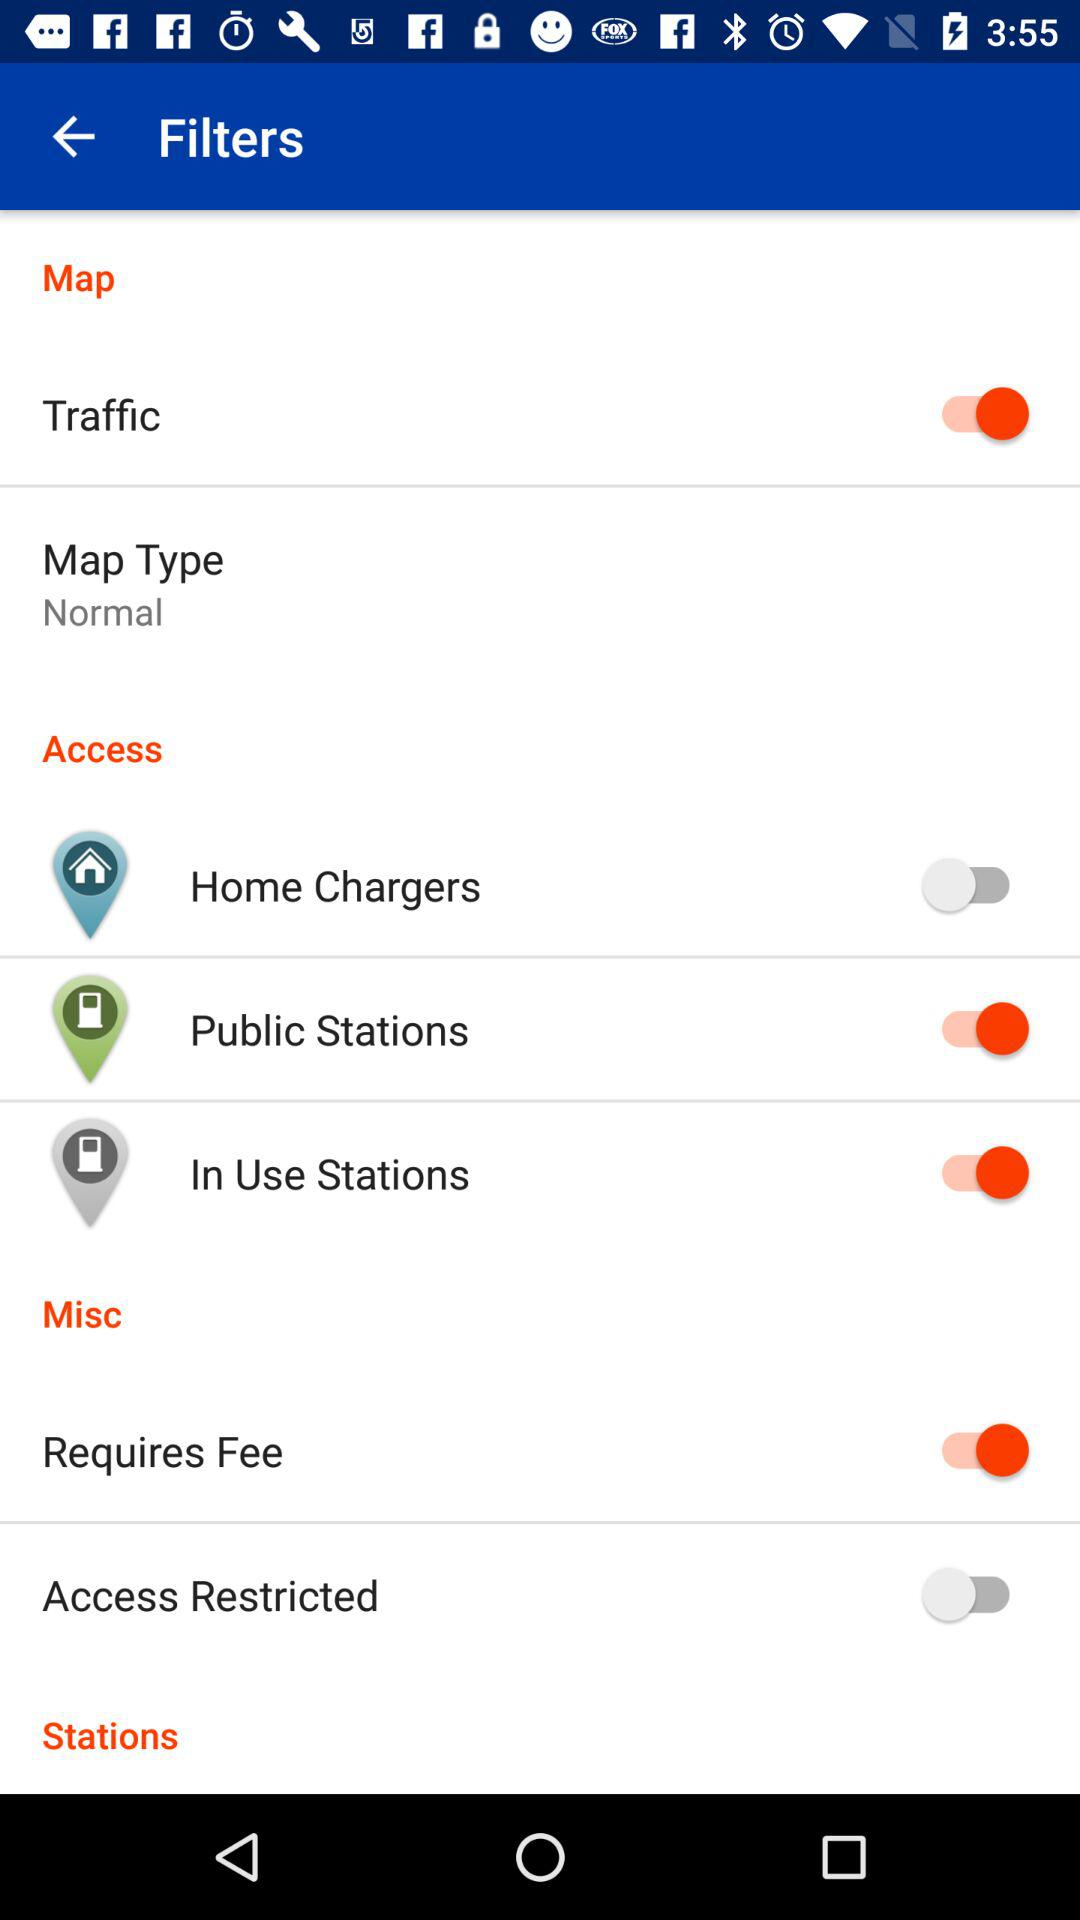What is the current status of the "Home Chargers"? The current status of the "Home Chargers" is "off". 